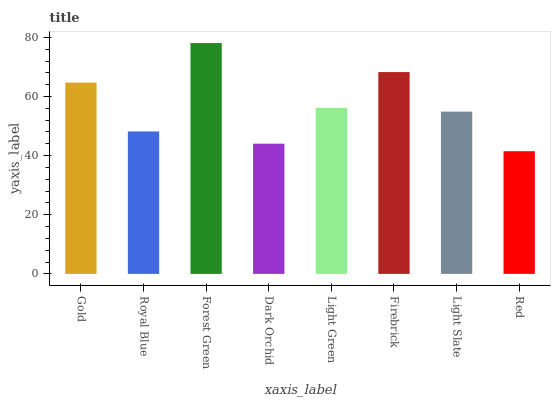Is Red the minimum?
Answer yes or no. Yes. Is Forest Green the maximum?
Answer yes or no. Yes. Is Royal Blue the minimum?
Answer yes or no. No. Is Royal Blue the maximum?
Answer yes or no. No. Is Gold greater than Royal Blue?
Answer yes or no. Yes. Is Royal Blue less than Gold?
Answer yes or no. Yes. Is Royal Blue greater than Gold?
Answer yes or no. No. Is Gold less than Royal Blue?
Answer yes or no. No. Is Light Green the high median?
Answer yes or no. Yes. Is Light Slate the low median?
Answer yes or no. Yes. Is Forest Green the high median?
Answer yes or no. No. Is Firebrick the low median?
Answer yes or no. No. 